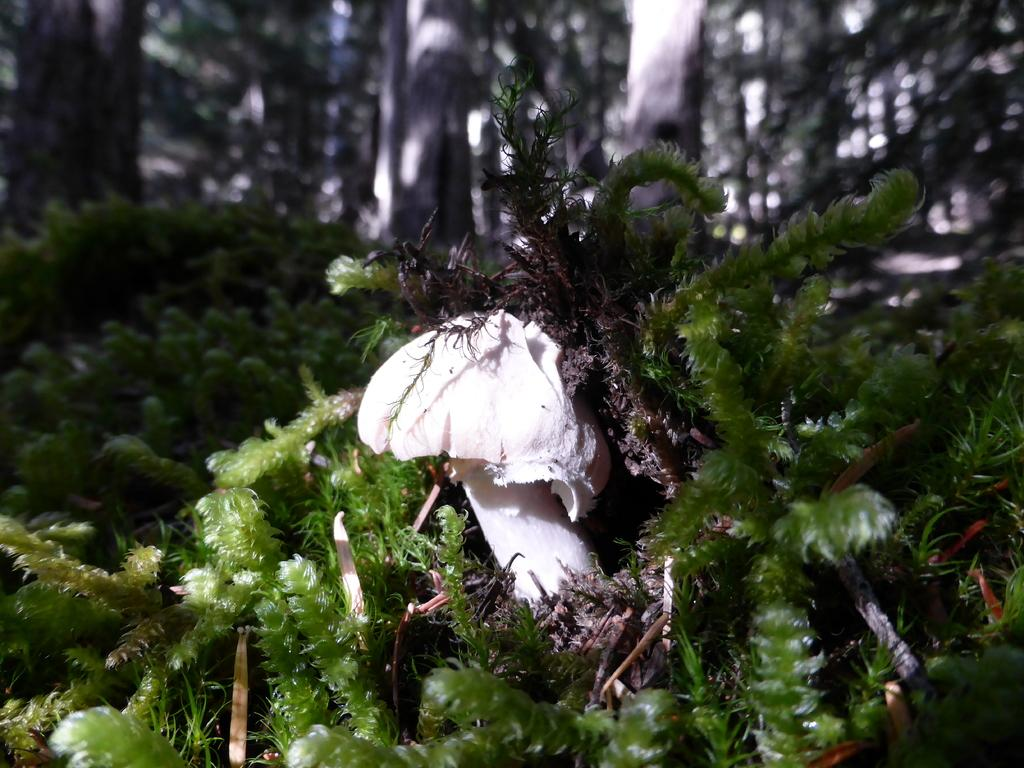What is the main subject in the middle of the image? There is a mushroom in the middle of the image. What other natural elements can be seen in the image? There are plants and trees in the image. How many family members are present in the image? There are no family members present in the image; it features a mushroom, plants, and trees. What type of guide is shown in the image? There is no guide present in the image; it features a mushroom, plants, and trees. 